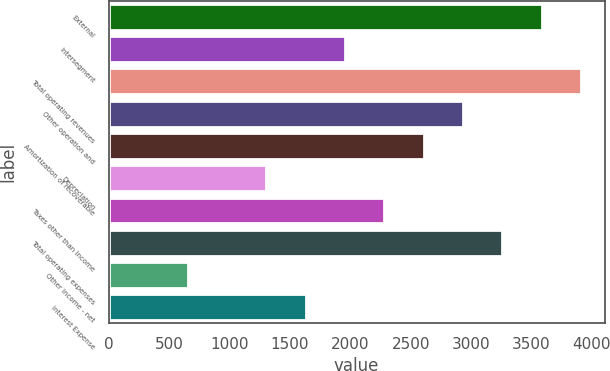Convert chart. <chart><loc_0><loc_0><loc_500><loc_500><bar_chart><fcel>External<fcel>Intersegment<fcel>Total operating revenues<fcel>Other operation and<fcel>Amortization of recoverable<fcel>Depreciation<fcel>Taxes other than income<fcel>Total operating expenses<fcel>Other Income - net<fcel>Interest Expense<nl><fcel>3584.5<fcel>1957<fcel>3910<fcel>2933.5<fcel>2608<fcel>1306<fcel>2282.5<fcel>3259<fcel>655<fcel>1631.5<nl></chart> 